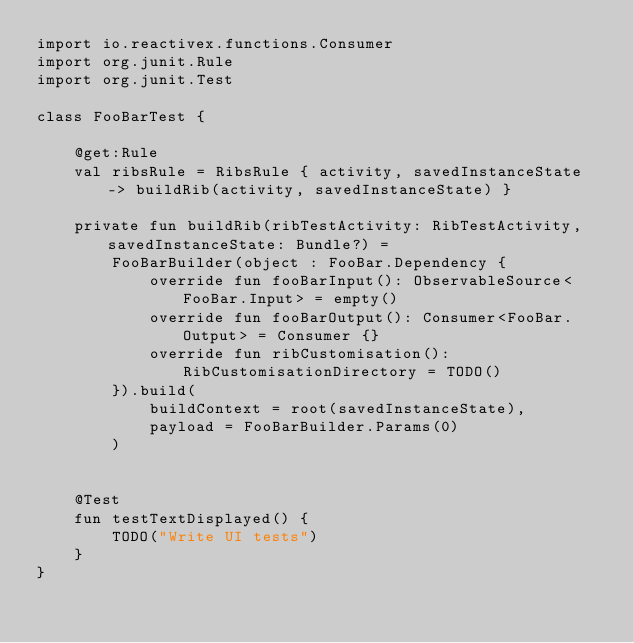Convert code to text. <code><loc_0><loc_0><loc_500><loc_500><_Kotlin_>import io.reactivex.functions.Consumer
import org.junit.Rule
import org.junit.Test

class FooBarTest {

    @get:Rule
    val ribsRule = RibsRule { activity, savedInstanceState -> buildRib(activity, savedInstanceState) }

    private fun buildRib(ribTestActivity: RibTestActivity, savedInstanceState: Bundle?) =
        FooBarBuilder(object : FooBar.Dependency {
            override fun fooBarInput(): ObservableSource<FooBar.Input> = empty()
            override fun fooBarOutput(): Consumer<FooBar.Output> = Consumer {}
            override fun ribCustomisation(): RibCustomisationDirectory = TODO()
        }).build(
            buildContext = root(savedInstanceState),
            payload = FooBarBuilder.Params(0)
        )


    @Test
    fun testTextDisplayed() {
        TODO("Write UI tests")
    }
}
</code> 